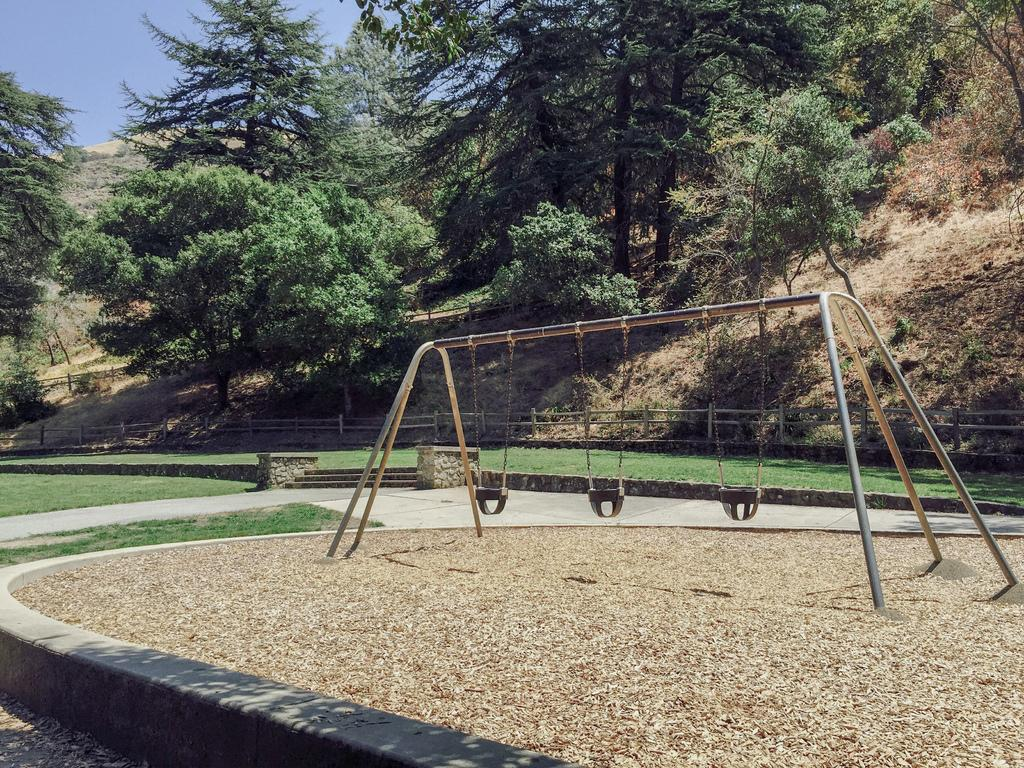What type of playground equipment can be seen in the image? There are swings attached to poles in the image. What type of ground surface is visible in the image? There is grass visible in the image. Can you describe any architectural features in the image? There is a staircase in the image. What type of barrier is present in the image? There is a fence in the image. What type of vegetation can be seen in the image besides grass? There is a group of trees and plants in the image. What is the condition of the sky in the image? The sky is visible in the image, and it appears cloudy. What type of cheese is being used to build the place in the image? There is no cheese present in the image, nor is there any indication of a place being built. What impulse might cause someone to jump on the swings in the image? The image does not provide information about the emotions or impulses of the people who might use the swings. 